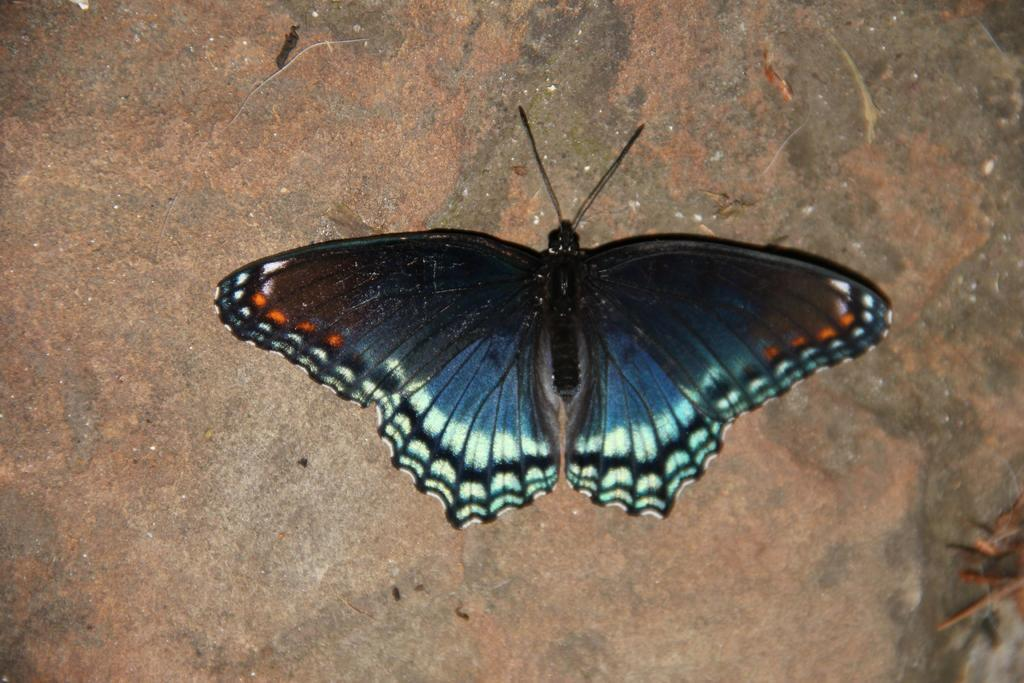What is present on the object in the image? There is a butterfly in the image, and it is on an object. Can you describe the object that the butterfly is on? The object looks like a rock. What type of brush is the governor using in the image? There is no governor or brush present in the image; it features a butterfly on a rock. What type of slip is visible on the rock in the image? There is no slip present in the image; it features a butterfly on a rock. 